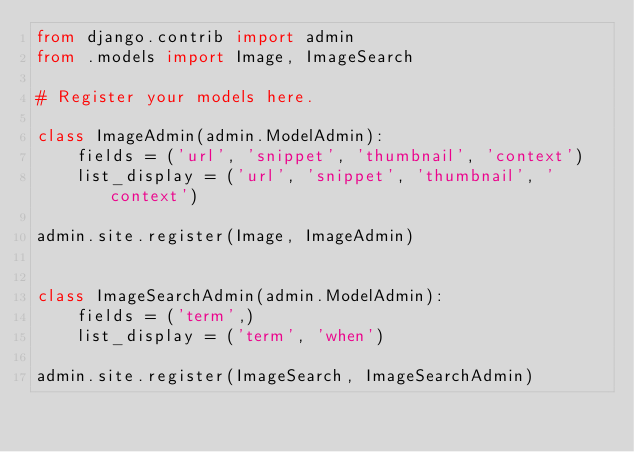Convert code to text. <code><loc_0><loc_0><loc_500><loc_500><_Python_>from django.contrib import admin
from .models import Image, ImageSearch

# Register your models here.

class ImageAdmin(admin.ModelAdmin):
    fields = ('url', 'snippet', 'thumbnail', 'context')
    list_display = ('url', 'snippet', 'thumbnail', 'context')

admin.site.register(Image, ImageAdmin)


class ImageSearchAdmin(admin.ModelAdmin):
    fields = ('term',)
    list_display = ('term', 'when')

admin.site.register(ImageSearch, ImageSearchAdmin)
</code> 